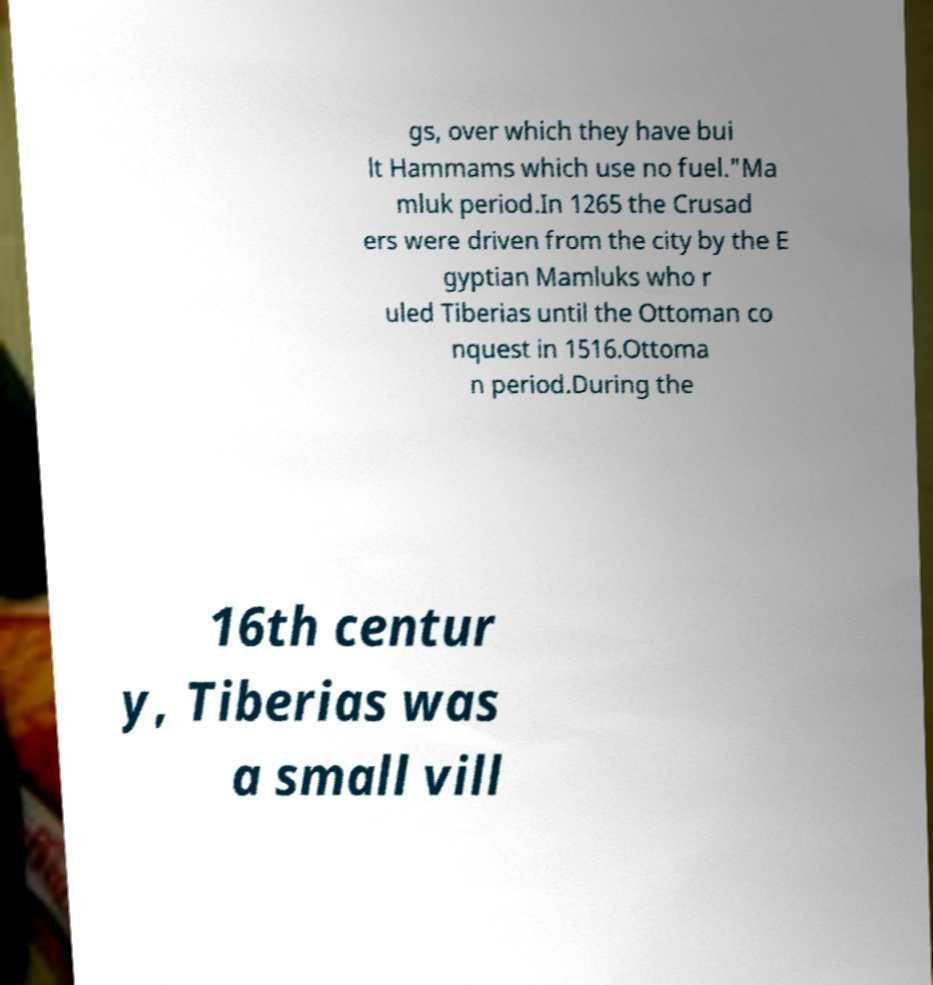Can you read and provide the text displayed in the image?This photo seems to have some interesting text. Can you extract and type it out for me? gs, over which they have bui lt Hammams which use no fuel."Ma mluk period.In 1265 the Crusad ers were driven from the city by the E gyptian Mamluks who r uled Tiberias until the Ottoman co nquest in 1516.Ottoma n period.During the 16th centur y, Tiberias was a small vill 